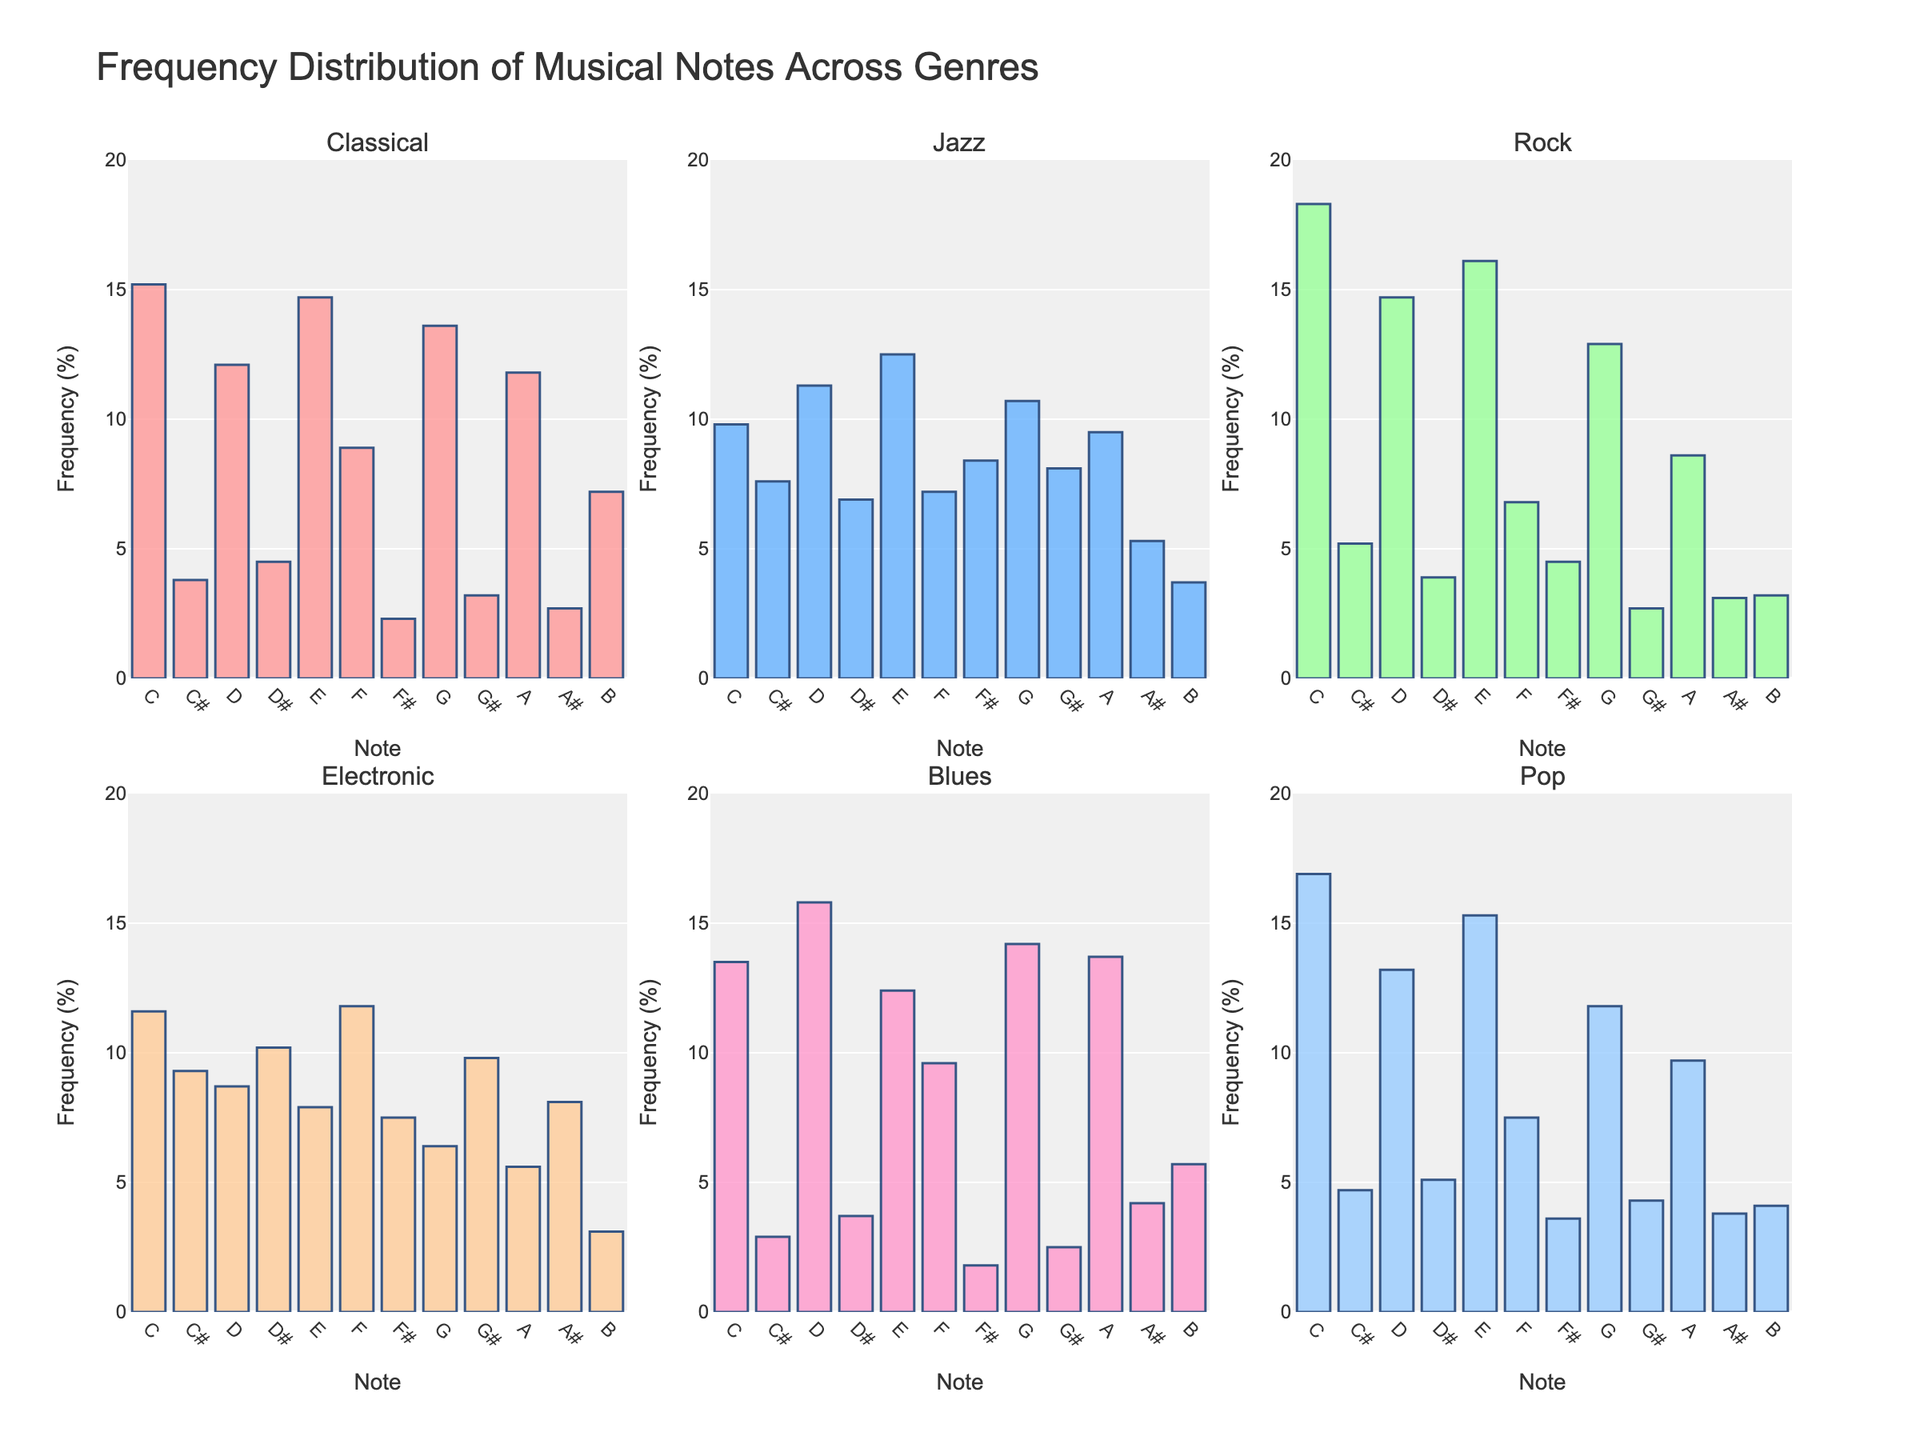What's the title of the figure? The figure has a clear title at the top which reads "Species Diversity in Different Ecosystems".
Answer: Species Diversity in Different Ecosystems Which ecosystem has the highest number of insect species? By examining the bars for the 'Insects' category across all subplots, the tallest bar is found in the Serengeti Plains subplot. So, Serengeti Plains has the highest number of insect species with 250,000 insects.
Answer: Serengeti Plains How many bird species are there in the Amazon Rainforest and the Great Barrier Reef combined? According to the individual subplots, the Amazon Rainforest has 1,300 bird species and the Great Barrier Reef has 215 bird species. Adding these values together: 1,300 + 215.
Answer: 1,515 Which ecosystem has the fewest number of mammal species? By comparing the bars for the 'Mammals' category across all subplots, the smallest bar is found in the Galapagos Islands subplot, which indicates 12 mammal species.
Answer: Galapagos Islands What is the difference in the number of reptile species between the Amazon Rainforest and the Mojave Desert? The Amazon Rainforest has 378 reptile species and the Mojave Desert has 58 reptile species. Calculating the difference: 378 - 58.
Answer: 320 Which taxonomic group has no species represented in the Arctic Tundra? Looking at the Arctic Tundra subplot, the bars for 'Reptiles' and 'Amphibians' are missing, indicating there are no species in these groups.
Answer: Reptiles and Amphibians Rank the ecosystems by the highest number of plant species from highest to lowest. By examining the plants bar in each subplot: Amazon Rainforest (40,000), Borneo Rainforest (15,000), Serengeti Plains (2,500), Everglades (1,650), Arctic Tundra (1,700), Mojave Desert (750), Galapagos Islands (500), Great Barrier Reef (450). Order them accordingly.
Answer: Amazon Rainforest, Borneo Rainforest, Serengeti Plains, Arctic Tundra, Everglades, Mojave Desert, Galapagos Islands, Great Barrier Reef Which ecosystem has the highest species diversity overall considering all taxonomic groups? To determine the highest diversity, observe all bars combined. The ecosystem with the most filled bars and highest values in general across all groups appears to be the Amazon Rainforest.
Answer: Amazon Rainforest 